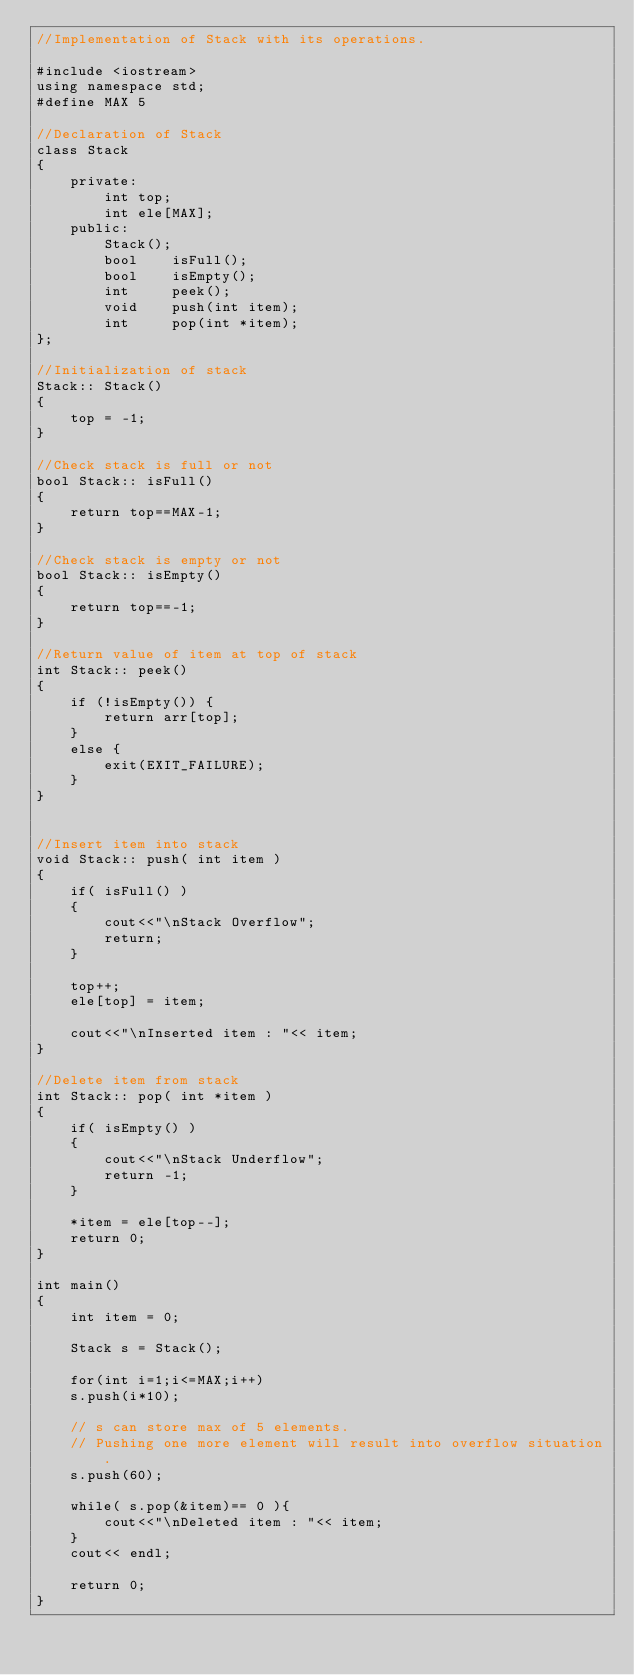<code> <loc_0><loc_0><loc_500><loc_500><_C++_>//Implementation of Stack with its operations.

#include <iostream>
using namespace std;
#define MAX 5

//Declaration of Stack
class Stack
{
    private:
        int top;
        int ele[MAX];
    public:
        Stack();
        bool    isFull();
        bool    isEmpty();
        int     peek();
        void    push(int item);
        int     pop(int *item);
};

//Initialization of stack
Stack:: Stack()
{
    top = -1;
}

//Check stack is full or not
bool Stack:: isFull()
{
    return top==MAX-1;
}

//Check stack is empty or not
bool Stack:: isEmpty()
{
    return top==-1;
}

//Return value of item at top of stack
int Stack:: peek()
{
    if (!isEmpty()) {
        return arr[top];
    }
    else {
        exit(EXIT_FAILURE);
    }
}


//Insert item into stack
void Stack:: push( int item )
{
    if( isFull() )
    {
        cout<<"\nStack Overflow";
        return;
    }

    top++;
    ele[top] = item;

    cout<<"\nInserted item : "<< item;
}

//Delete item from stack
int Stack:: pop( int *item )
{
    if( isEmpty() )
    {
        cout<<"\nStack Underflow";
        return -1;
    }

    *item = ele[top--];
    return 0;
}

int main()
{
    int item = 0;

    Stack s = Stack();

    for(int i=1;i<=MAX;i++)
    s.push(i*10);

    // s can store max of 5 elements.
    // Pushing one more element will result into overflow situation.
    s.push(60);

    while( s.pop(&item)== 0 ){
        cout<<"\nDeleted item : "<< item;
    }
    cout<< endl;

    return 0;
}
</code> 